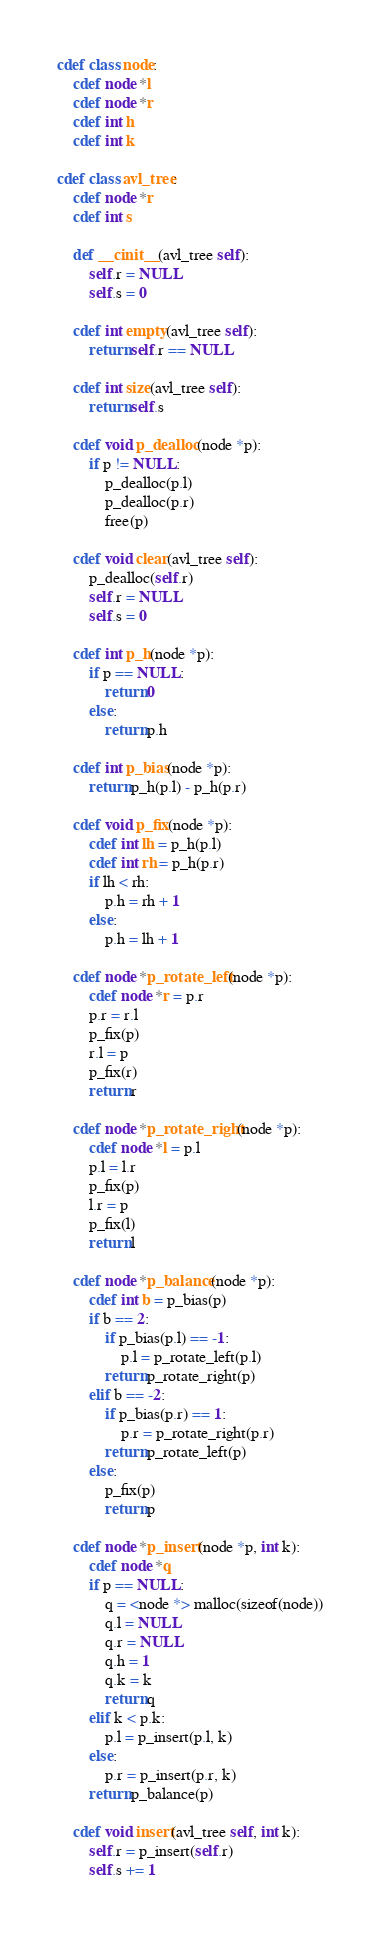Convert code to text. <code><loc_0><loc_0><loc_500><loc_500><_Cython_>cdef class node:
    cdef node *l
    cdef node *r
    cdef int h
    cdef int k

cdef class avl_tree:
    cdef node *r
    cdef int s

    def __cinit__(avl_tree self):
        self.r = NULL
        self.s = 0
    
    cdef int empty(avl_tree self):
        return self.r == NULL

    cdef int size(avl_tree self):
        return self.s
    
    cdef void p_dealloc(node *p):
        if p != NULL:
            p_dealloc(p.l)
            p_dealloc(p.r)
            free(p)
    
    cdef void clear(avl_tree self):
        p_dealloc(self.r)
        self.r = NULL
        self.s = 0

    cdef int p_h(node *p):
        if p == NULL:
            return 0
        else:
            return p.h
    
    cdef int p_bias(node *p):
        return p_h(p.l) - p_h(p.r)
    
    cdef void p_fix(node *p):
        cdef int lh = p_h(p.l)
        cdef int rh = p_h(p.r)
        if lh < rh:
            p.h = rh + 1
        else:
            p.h = lh + 1
    
    cdef node *p_rotate_left(node *p):
        cdef node *r = p.r
        p.r = r.l
        p_fix(p)
        r.l = p
        p_fix(r)
        return r
    
    cdef node *p_rotate_right(node *p):
        cdef node *l = p.l
        p.l = l.r
        p_fix(p)
        l.r = p
        p_fix(l)
        return l

    cdef node *p_balance(node *p):
        cdef int b = p_bias(p)
        if b == 2:
            if p_bias(p.l) == -1:
                p.l = p_rotate_left(p.l)
            return p_rotate_right(p)
        elif b == -2:
            if p_bias(p.r) == 1:
                p.r = p_rotate_right(p.r)
            return p_rotate_left(p)
        else:
            p_fix(p)
            return p
    
    cdef node *p_insert(node *p, int k):
        cdef node *q
        if p == NULL:
            q = <node *> malloc(sizeof(node))
            q.l = NULL
            q.r = NULL
            q.h = 1
            q.k = k
            return q
        elif k < p.k:
            p.l = p_insert(p.l, k)
        else:
            p.r = p_insert(p.r, k)
        return p_balance(p)
    
    cdef void insert(avl_tree self, int k):
        self.r = p_insert(self.r)
        self.s += 1
    

</code> 